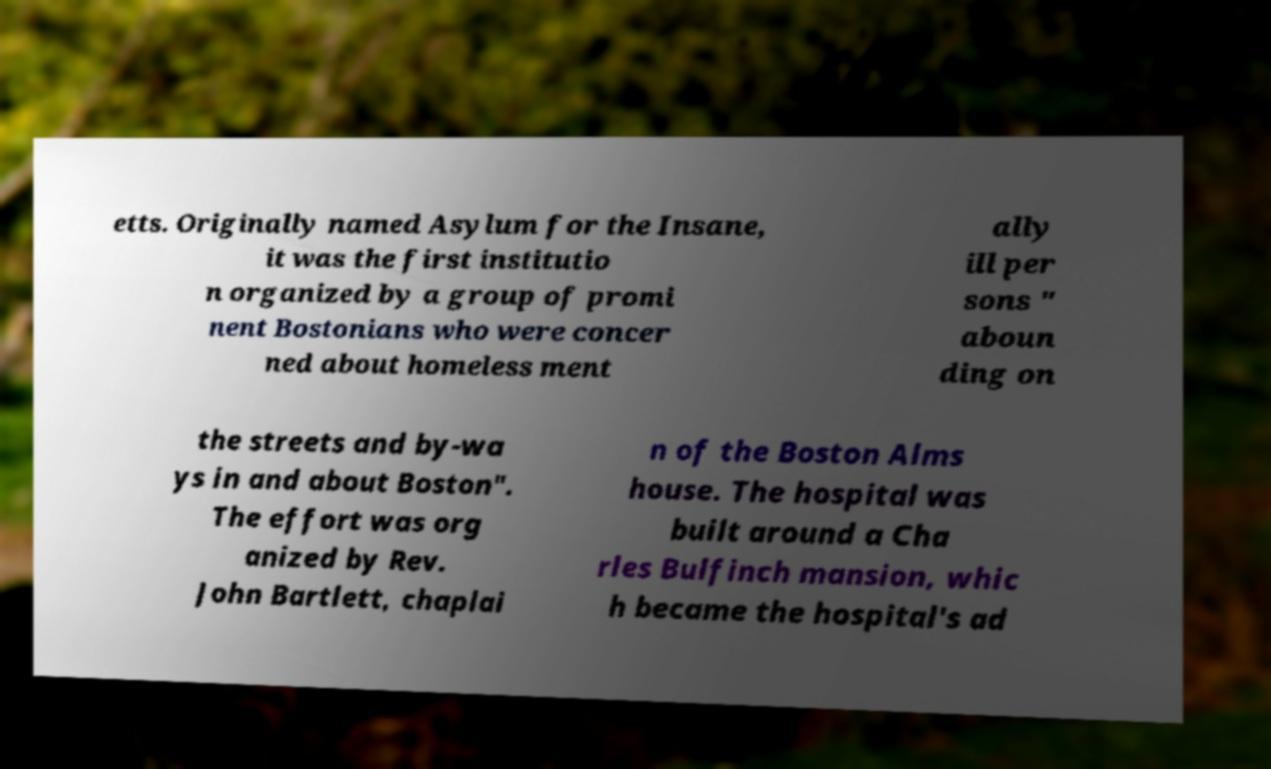Can you accurately transcribe the text from the provided image for me? etts. Originally named Asylum for the Insane, it was the first institutio n organized by a group of promi nent Bostonians who were concer ned about homeless ment ally ill per sons " aboun ding on the streets and by-wa ys in and about Boston". The effort was org anized by Rev. John Bartlett, chaplai n of the Boston Alms house. The hospital was built around a Cha rles Bulfinch mansion, whic h became the hospital's ad 